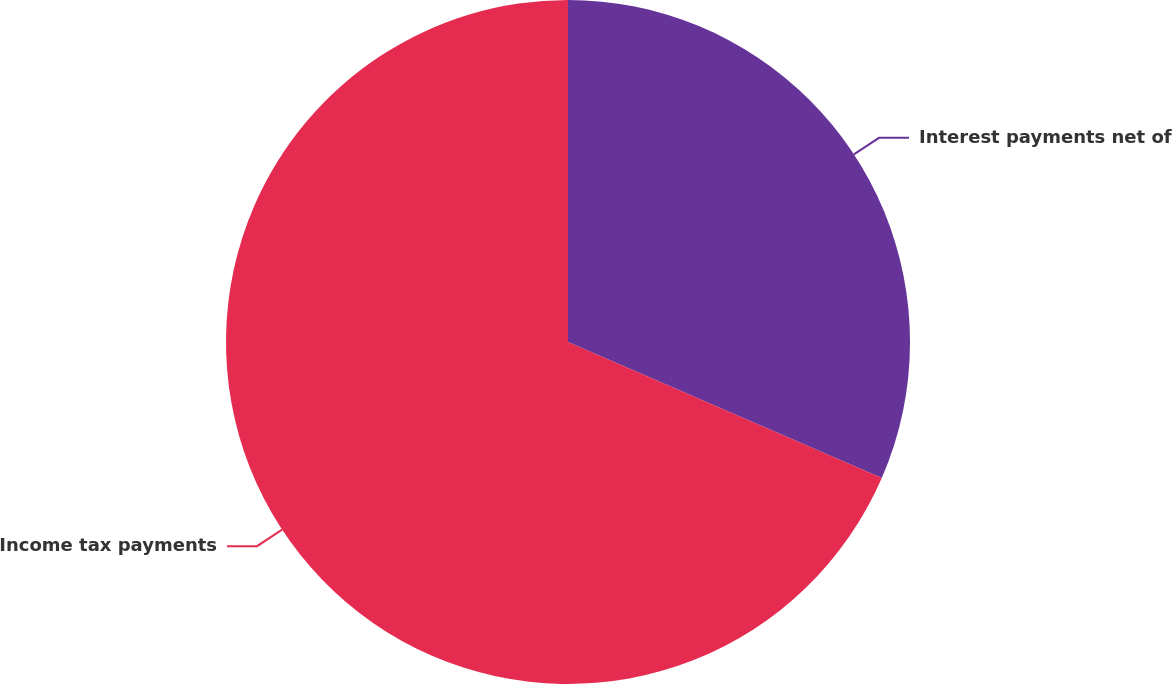Convert chart to OTSL. <chart><loc_0><loc_0><loc_500><loc_500><pie_chart><fcel>Interest payments net of<fcel>Income tax payments<nl><fcel>31.51%<fcel>68.49%<nl></chart> 